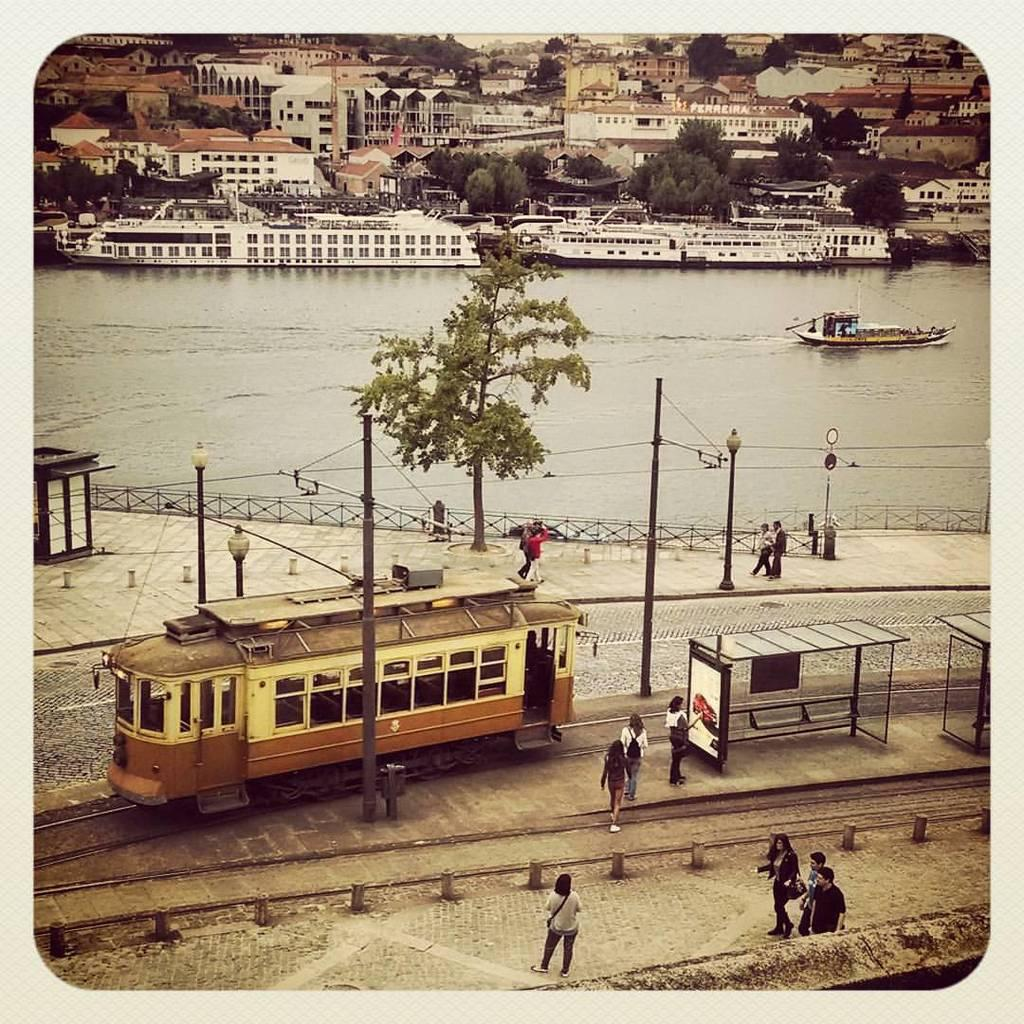What are the people in the image doing? The people in the image are walking. What can be seen in the water in the image? There is a boat visible in the water. What type of structures can be seen in the image? There are buildings in the image. What type of vegetation is present in the image? There are green color trees in the image. What type of pot is being used by the farmer in the image? There is no farmer or pot present in the image. What type of lumber is being transported by the boat in the image? There is no lumber visible in the image; only a boat is present in the water. 